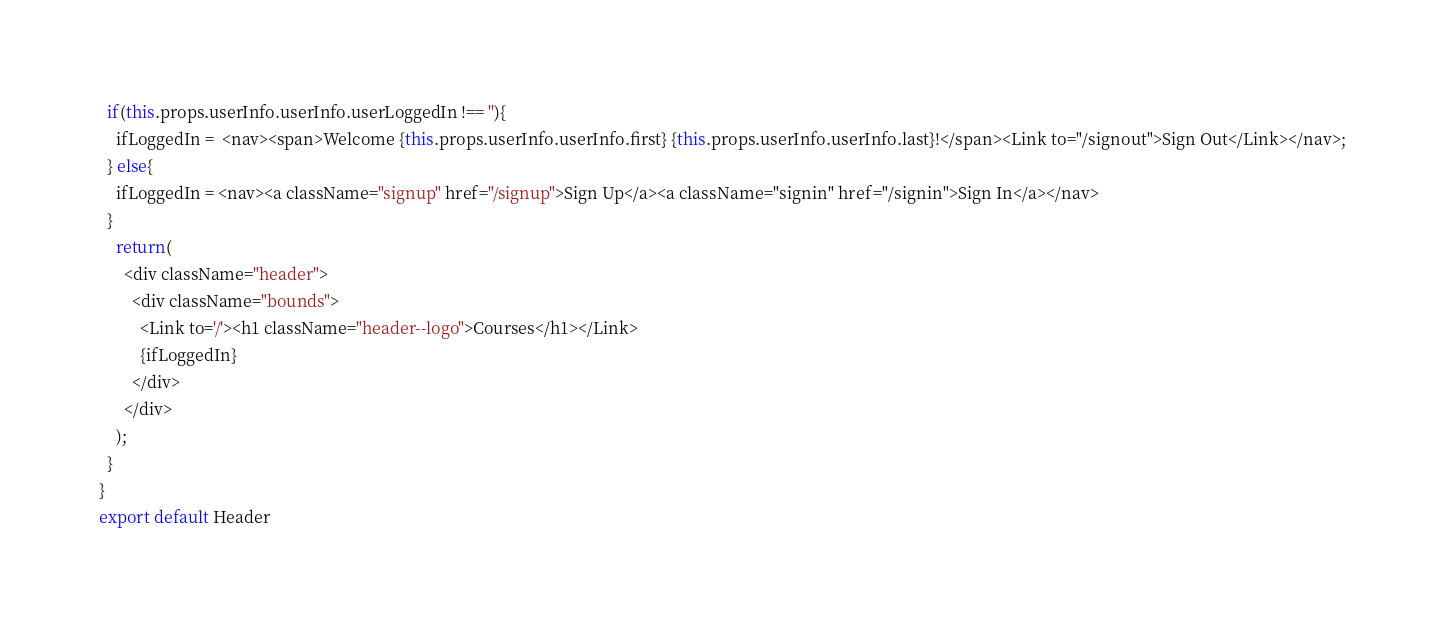<code> <loc_0><loc_0><loc_500><loc_500><_JavaScript_>  if(this.props.userInfo.userInfo.userLoggedIn !== ''){
    ifLoggedIn =  <nav><span>Welcome {this.props.userInfo.userInfo.first} {this.props.userInfo.userInfo.last}!</span><Link to="/signout">Sign Out</Link></nav>;
  } else{
    ifLoggedIn = <nav><a className="signup" href="/signup">Sign Up</a><a className="signin" href="/signin">Sign In</a></nav>
  }
    return(
      <div className="header">
        <div className="bounds">
          <Link to='/'><h1 className="header--logo">Courses</h1></Link>
          {ifLoggedIn}
        </div>
      </div>
    );
  }
}
export default Header</code> 